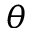<formula> <loc_0><loc_0><loc_500><loc_500>\theta</formula> 